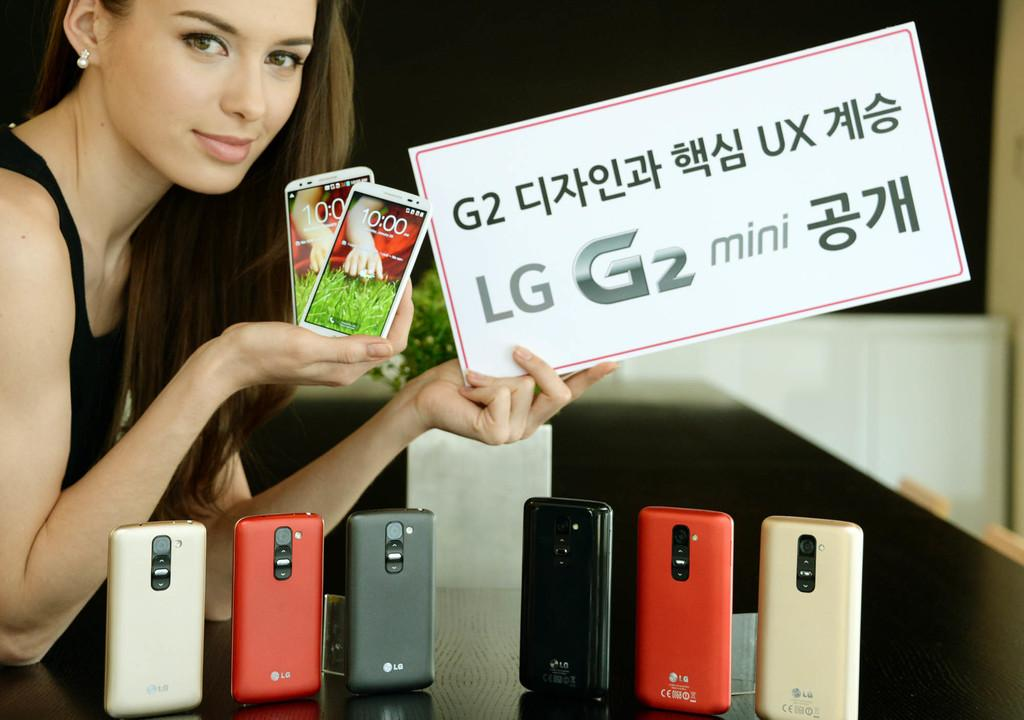<image>
Share a concise interpretation of the image provided. A woman holds up multiple phones and a sign that says LG G2 Mini. 